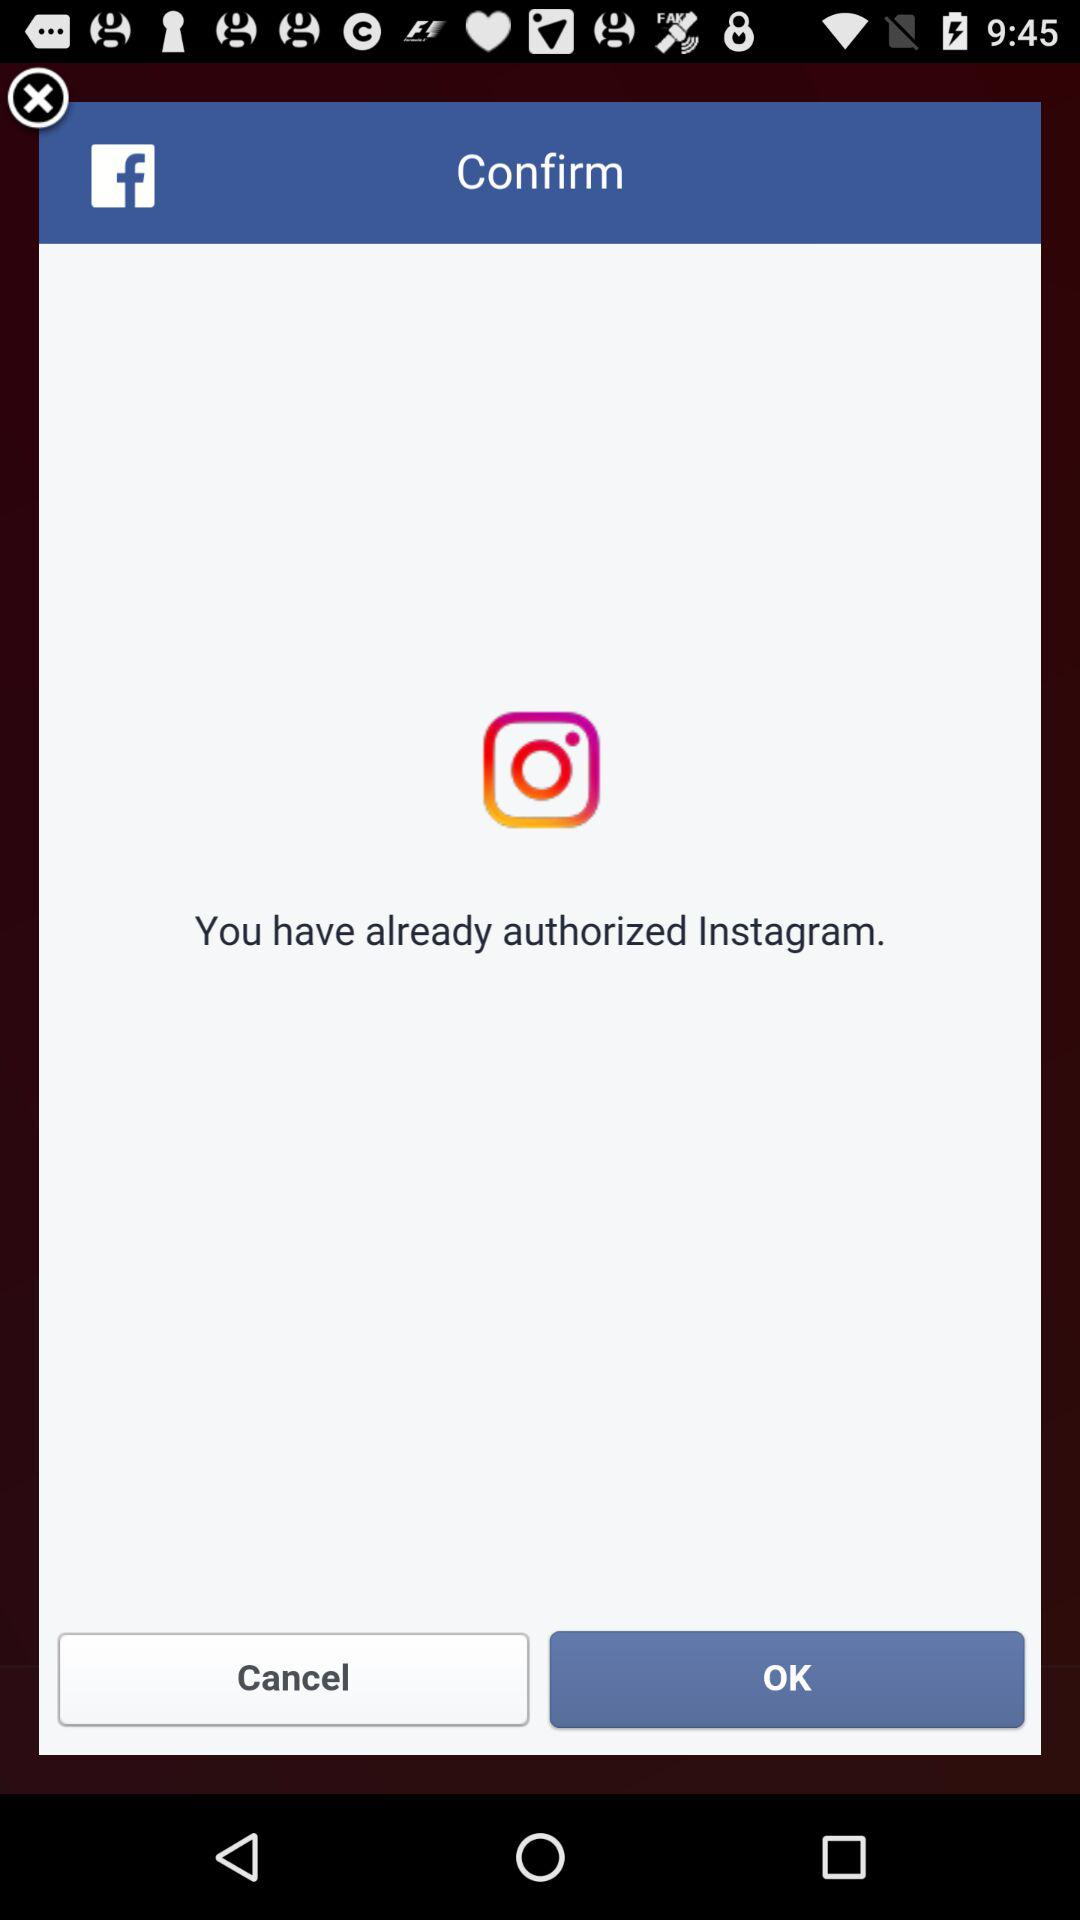What application has already been authorized? The application that has already been authorized is "Instagram". 